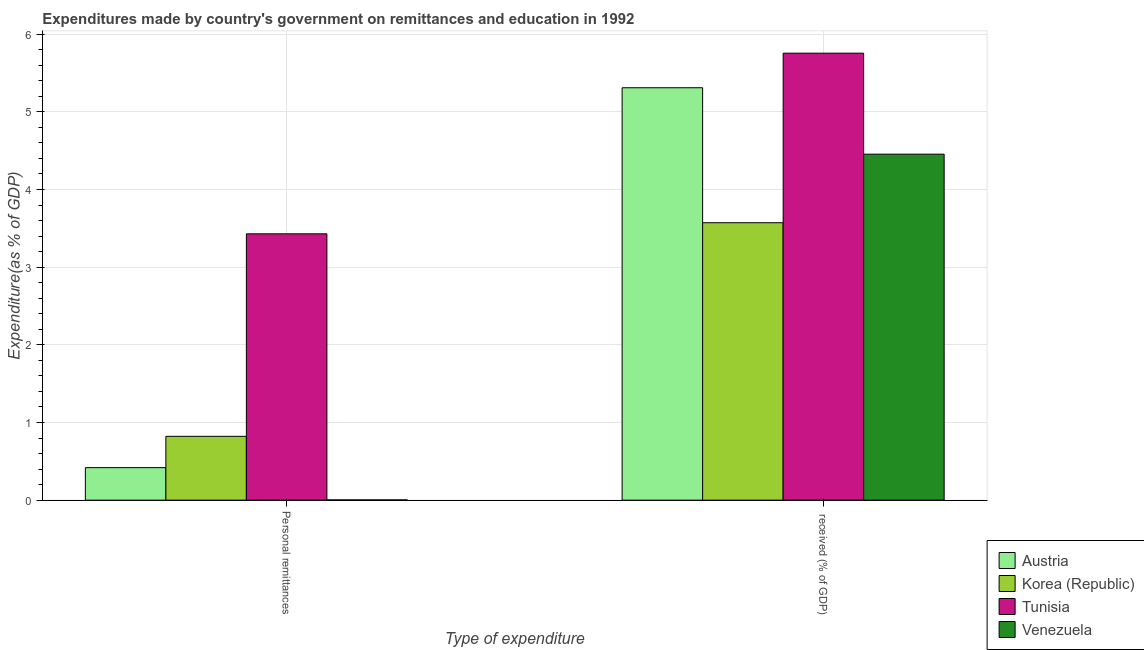How many groups of bars are there?
Make the answer very short. 2. Are the number of bars per tick equal to the number of legend labels?
Offer a terse response. Yes. How many bars are there on the 1st tick from the left?
Provide a succinct answer. 4. What is the label of the 2nd group of bars from the left?
Ensure brevity in your answer.   received (% of GDP). What is the expenditure in personal remittances in Venezuela?
Your answer should be compact. 0. Across all countries, what is the maximum expenditure in personal remittances?
Make the answer very short. 3.43. Across all countries, what is the minimum expenditure in education?
Make the answer very short. 3.57. In which country was the expenditure in personal remittances maximum?
Ensure brevity in your answer.  Tunisia. In which country was the expenditure in education minimum?
Provide a short and direct response. Korea (Republic). What is the total expenditure in education in the graph?
Offer a very short reply. 19.09. What is the difference between the expenditure in education in Tunisia and that in Austria?
Offer a very short reply. 0.45. What is the difference between the expenditure in personal remittances in Venezuela and the expenditure in education in Austria?
Make the answer very short. -5.31. What is the average expenditure in education per country?
Your answer should be very brief. 4.77. What is the difference between the expenditure in education and expenditure in personal remittances in Korea (Republic)?
Ensure brevity in your answer.  2.75. What is the ratio of the expenditure in personal remittances in Austria to that in Korea (Republic)?
Offer a terse response. 0.51. In how many countries, is the expenditure in education greater than the average expenditure in education taken over all countries?
Offer a very short reply. 2. What does the 3rd bar from the right in Personal remittances represents?
Your answer should be compact. Korea (Republic). How many bars are there?
Give a very brief answer. 8. Are all the bars in the graph horizontal?
Your answer should be very brief. No. What is the difference between two consecutive major ticks on the Y-axis?
Give a very brief answer. 1. Are the values on the major ticks of Y-axis written in scientific E-notation?
Make the answer very short. No. Does the graph contain any zero values?
Offer a very short reply. No. Does the graph contain grids?
Keep it short and to the point. Yes. How many legend labels are there?
Keep it short and to the point. 4. What is the title of the graph?
Offer a terse response. Expenditures made by country's government on remittances and education in 1992. What is the label or title of the X-axis?
Provide a short and direct response. Type of expenditure. What is the label or title of the Y-axis?
Make the answer very short. Expenditure(as % of GDP). What is the Expenditure(as % of GDP) in Austria in Personal remittances?
Your response must be concise. 0.42. What is the Expenditure(as % of GDP) in Korea (Republic) in Personal remittances?
Keep it short and to the point. 0.82. What is the Expenditure(as % of GDP) of Tunisia in Personal remittances?
Your answer should be very brief. 3.43. What is the Expenditure(as % of GDP) of Venezuela in Personal remittances?
Your response must be concise. 0. What is the Expenditure(as % of GDP) of Austria in  received (% of GDP)?
Provide a short and direct response. 5.31. What is the Expenditure(as % of GDP) in Korea (Republic) in  received (% of GDP)?
Give a very brief answer. 3.57. What is the Expenditure(as % of GDP) in Tunisia in  received (% of GDP)?
Make the answer very short. 5.75. What is the Expenditure(as % of GDP) of Venezuela in  received (% of GDP)?
Offer a terse response. 4.45. Across all Type of expenditure, what is the maximum Expenditure(as % of GDP) in Austria?
Provide a succinct answer. 5.31. Across all Type of expenditure, what is the maximum Expenditure(as % of GDP) of Korea (Republic)?
Make the answer very short. 3.57. Across all Type of expenditure, what is the maximum Expenditure(as % of GDP) of Tunisia?
Your answer should be compact. 5.75. Across all Type of expenditure, what is the maximum Expenditure(as % of GDP) of Venezuela?
Ensure brevity in your answer.  4.45. Across all Type of expenditure, what is the minimum Expenditure(as % of GDP) in Austria?
Ensure brevity in your answer.  0.42. Across all Type of expenditure, what is the minimum Expenditure(as % of GDP) of Korea (Republic)?
Provide a succinct answer. 0.82. Across all Type of expenditure, what is the minimum Expenditure(as % of GDP) of Tunisia?
Ensure brevity in your answer.  3.43. Across all Type of expenditure, what is the minimum Expenditure(as % of GDP) in Venezuela?
Offer a terse response. 0. What is the total Expenditure(as % of GDP) in Austria in the graph?
Offer a very short reply. 5.73. What is the total Expenditure(as % of GDP) of Korea (Republic) in the graph?
Give a very brief answer. 4.39. What is the total Expenditure(as % of GDP) of Tunisia in the graph?
Keep it short and to the point. 9.18. What is the total Expenditure(as % of GDP) in Venezuela in the graph?
Provide a short and direct response. 4.46. What is the difference between the Expenditure(as % of GDP) of Austria in Personal remittances and that in  received (% of GDP)?
Provide a succinct answer. -4.89. What is the difference between the Expenditure(as % of GDP) in Korea (Republic) in Personal remittances and that in  received (% of GDP)?
Your answer should be compact. -2.75. What is the difference between the Expenditure(as % of GDP) in Tunisia in Personal remittances and that in  received (% of GDP)?
Ensure brevity in your answer.  -2.33. What is the difference between the Expenditure(as % of GDP) in Venezuela in Personal remittances and that in  received (% of GDP)?
Offer a terse response. -4.45. What is the difference between the Expenditure(as % of GDP) of Austria in Personal remittances and the Expenditure(as % of GDP) of Korea (Republic) in  received (% of GDP)?
Offer a terse response. -3.15. What is the difference between the Expenditure(as % of GDP) of Austria in Personal remittances and the Expenditure(as % of GDP) of Tunisia in  received (% of GDP)?
Your answer should be very brief. -5.34. What is the difference between the Expenditure(as % of GDP) in Austria in Personal remittances and the Expenditure(as % of GDP) in Venezuela in  received (% of GDP)?
Ensure brevity in your answer.  -4.04. What is the difference between the Expenditure(as % of GDP) of Korea (Republic) in Personal remittances and the Expenditure(as % of GDP) of Tunisia in  received (% of GDP)?
Provide a succinct answer. -4.93. What is the difference between the Expenditure(as % of GDP) in Korea (Republic) in Personal remittances and the Expenditure(as % of GDP) in Venezuela in  received (% of GDP)?
Your response must be concise. -3.63. What is the difference between the Expenditure(as % of GDP) of Tunisia in Personal remittances and the Expenditure(as % of GDP) of Venezuela in  received (% of GDP)?
Provide a succinct answer. -1.03. What is the average Expenditure(as % of GDP) of Austria per Type of expenditure?
Your answer should be very brief. 2.86. What is the average Expenditure(as % of GDP) in Korea (Republic) per Type of expenditure?
Ensure brevity in your answer.  2.2. What is the average Expenditure(as % of GDP) in Tunisia per Type of expenditure?
Make the answer very short. 4.59. What is the average Expenditure(as % of GDP) of Venezuela per Type of expenditure?
Your answer should be compact. 2.23. What is the difference between the Expenditure(as % of GDP) in Austria and Expenditure(as % of GDP) in Korea (Republic) in Personal remittances?
Make the answer very short. -0.4. What is the difference between the Expenditure(as % of GDP) of Austria and Expenditure(as % of GDP) of Tunisia in Personal remittances?
Give a very brief answer. -3.01. What is the difference between the Expenditure(as % of GDP) of Austria and Expenditure(as % of GDP) of Venezuela in Personal remittances?
Give a very brief answer. 0.42. What is the difference between the Expenditure(as % of GDP) of Korea (Republic) and Expenditure(as % of GDP) of Tunisia in Personal remittances?
Provide a succinct answer. -2.61. What is the difference between the Expenditure(as % of GDP) in Korea (Republic) and Expenditure(as % of GDP) in Venezuela in Personal remittances?
Ensure brevity in your answer.  0.82. What is the difference between the Expenditure(as % of GDP) of Tunisia and Expenditure(as % of GDP) of Venezuela in Personal remittances?
Make the answer very short. 3.43. What is the difference between the Expenditure(as % of GDP) of Austria and Expenditure(as % of GDP) of Korea (Republic) in  received (% of GDP)?
Your answer should be very brief. 1.74. What is the difference between the Expenditure(as % of GDP) in Austria and Expenditure(as % of GDP) in Tunisia in  received (% of GDP)?
Make the answer very short. -0.45. What is the difference between the Expenditure(as % of GDP) of Austria and Expenditure(as % of GDP) of Venezuela in  received (% of GDP)?
Ensure brevity in your answer.  0.86. What is the difference between the Expenditure(as % of GDP) of Korea (Republic) and Expenditure(as % of GDP) of Tunisia in  received (% of GDP)?
Provide a short and direct response. -2.18. What is the difference between the Expenditure(as % of GDP) in Korea (Republic) and Expenditure(as % of GDP) in Venezuela in  received (% of GDP)?
Your answer should be very brief. -0.88. What is the difference between the Expenditure(as % of GDP) in Tunisia and Expenditure(as % of GDP) in Venezuela in  received (% of GDP)?
Your answer should be very brief. 1.3. What is the ratio of the Expenditure(as % of GDP) of Austria in Personal remittances to that in  received (% of GDP)?
Your answer should be compact. 0.08. What is the ratio of the Expenditure(as % of GDP) of Korea (Republic) in Personal remittances to that in  received (% of GDP)?
Give a very brief answer. 0.23. What is the ratio of the Expenditure(as % of GDP) of Tunisia in Personal remittances to that in  received (% of GDP)?
Ensure brevity in your answer.  0.6. What is the ratio of the Expenditure(as % of GDP) of Venezuela in Personal remittances to that in  received (% of GDP)?
Ensure brevity in your answer.  0. What is the difference between the highest and the second highest Expenditure(as % of GDP) of Austria?
Make the answer very short. 4.89. What is the difference between the highest and the second highest Expenditure(as % of GDP) in Korea (Republic)?
Ensure brevity in your answer.  2.75. What is the difference between the highest and the second highest Expenditure(as % of GDP) of Tunisia?
Make the answer very short. 2.33. What is the difference between the highest and the second highest Expenditure(as % of GDP) of Venezuela?
Keep it short and to the point. 4.45. What is the difference between the highest and the lowest Expenditure(as % of GDP) in Austria?
Give a very brief answer. 4.89. What is the difference between the highest and the lowest Expenditure(as % of GDP) in Korea (Republic)?
Offer a very short reply. 2.75. What is the difference between the highest and the lowest Expenditure(as % of GDP) in Tunisia?
Ensure brevity in your answer.  2.33. What is the difference between the highest and the lowest Expenditure(as % of GDP) in Venezuela?
Your answer should be compact. 4.45. 